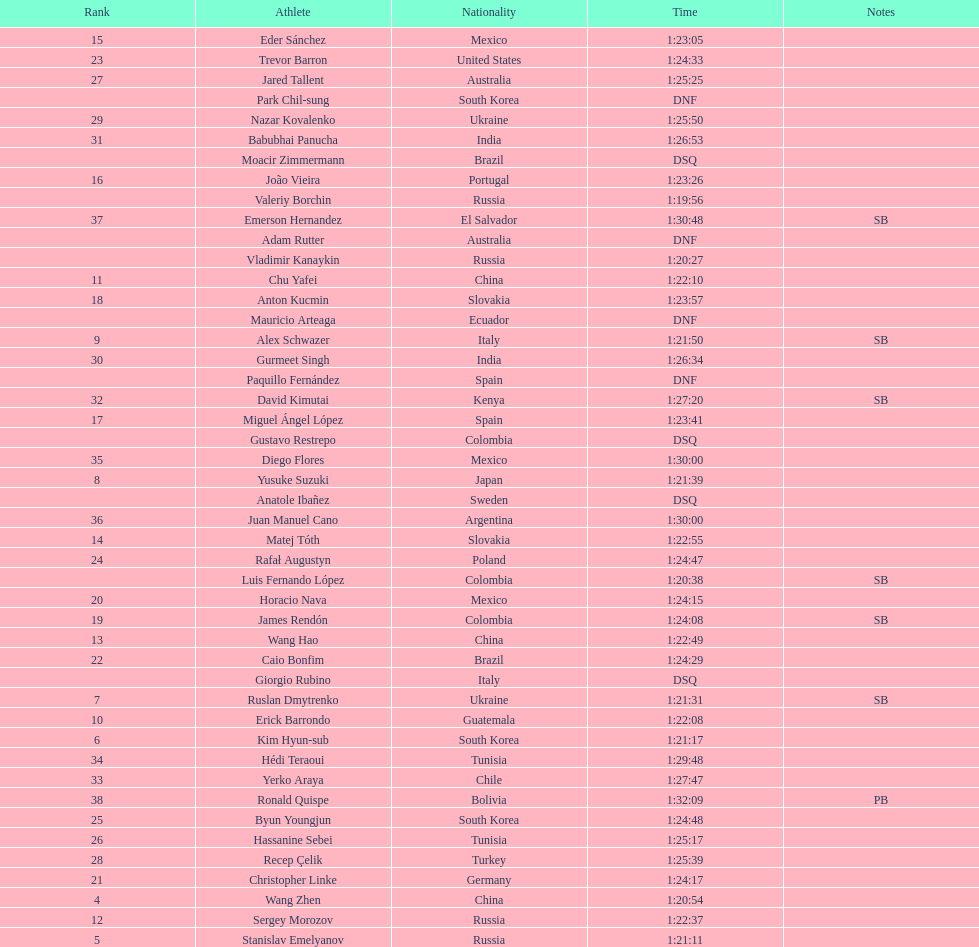Which competitor was ranked first? Valeriy Borchin. 